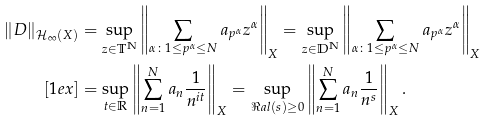Convert formula to latex. <formula><loc_0><loc_0><loc_500><loc_500>\| D \| _ { \mathcal { H } _ { \infty } ( X ) } & = \sup _ { z \in \mathbb { T } ^ { \mathbb { N } } } \left \| \sum _ { \alpha \colon 1 \leq p ^ { \alpha } \leq N } a _ { p ^ { \alpha } } z ^ { \alpha } \right \| _ { X } = \sup _ { z \in \mathbb { D } ^ { \mathbb { N } } } \left \| \sum _ { \alpha \colon 1 \leq p ^ { \alpha } \leq N } a _ { p ^ { \alpha } } z ^ { \alpha } \right \| _ { X } \\ [ 1 e x ] & = \sup _ { t \in \mathbb { R } } { \left \| \sum _ { n = 1 } ^ { N } { a _ { n } \frac { 1 } { n ^ { i t } } } \right \| _ { X } } = \sup _ { \Re a l { ( s ) } \geq 0 } { \left \| \sum _ { n = 1 } ^ { N } { a _ { n } \frac { 1 } { n ^ { s } } } \right \| _ { X } } \, .</formula> 